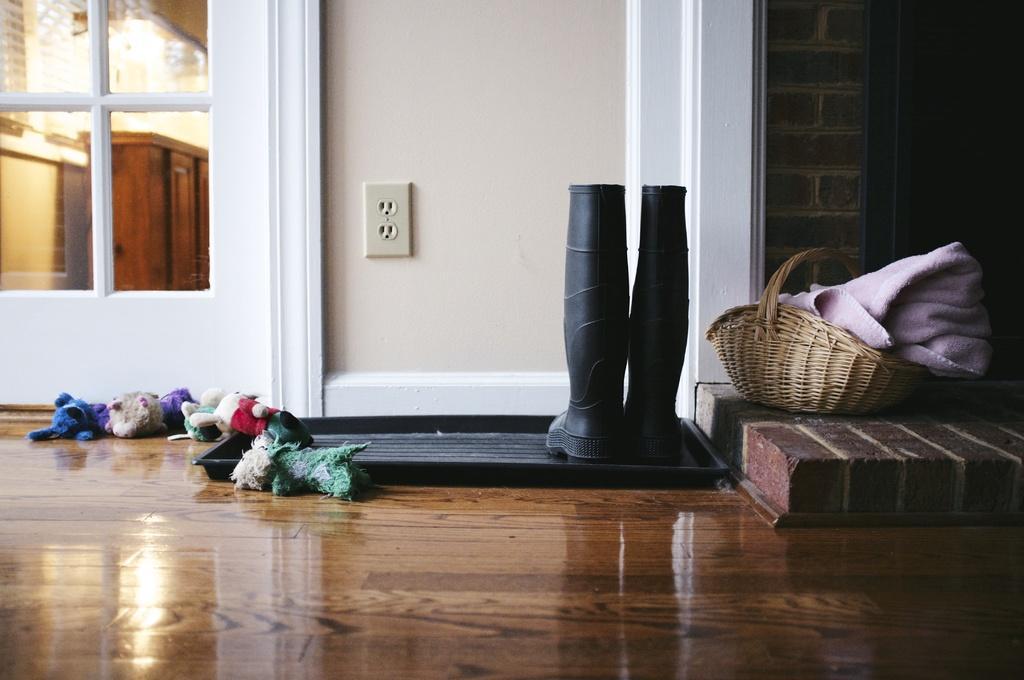Could you give a brief overview of what you see in this image? On the right side of the image, we can see one solid structure. On the solid structure, we can see one basket and one cloth. In the center of the image, we can see one black color plate on the floor. On the plate, we can see the pair of boots. In the background there is a wall, switchboard, black color object, grass and dolls. Through the glass, we can see one wooden object and a few other objects. 